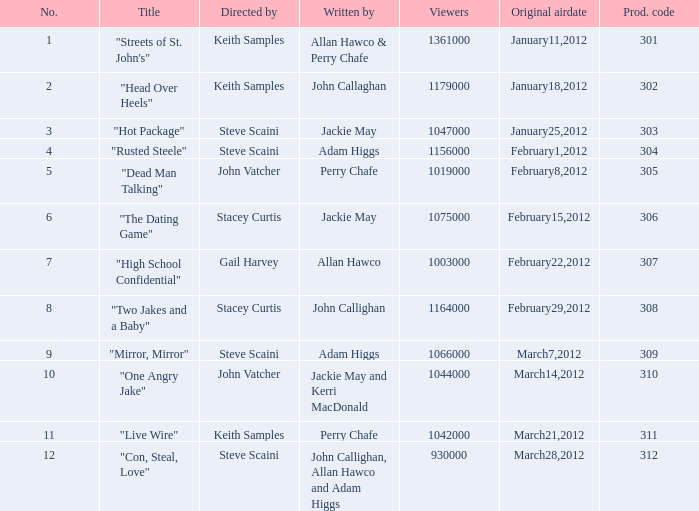What is the number of original airdate written by allan hawco? 1.0. 